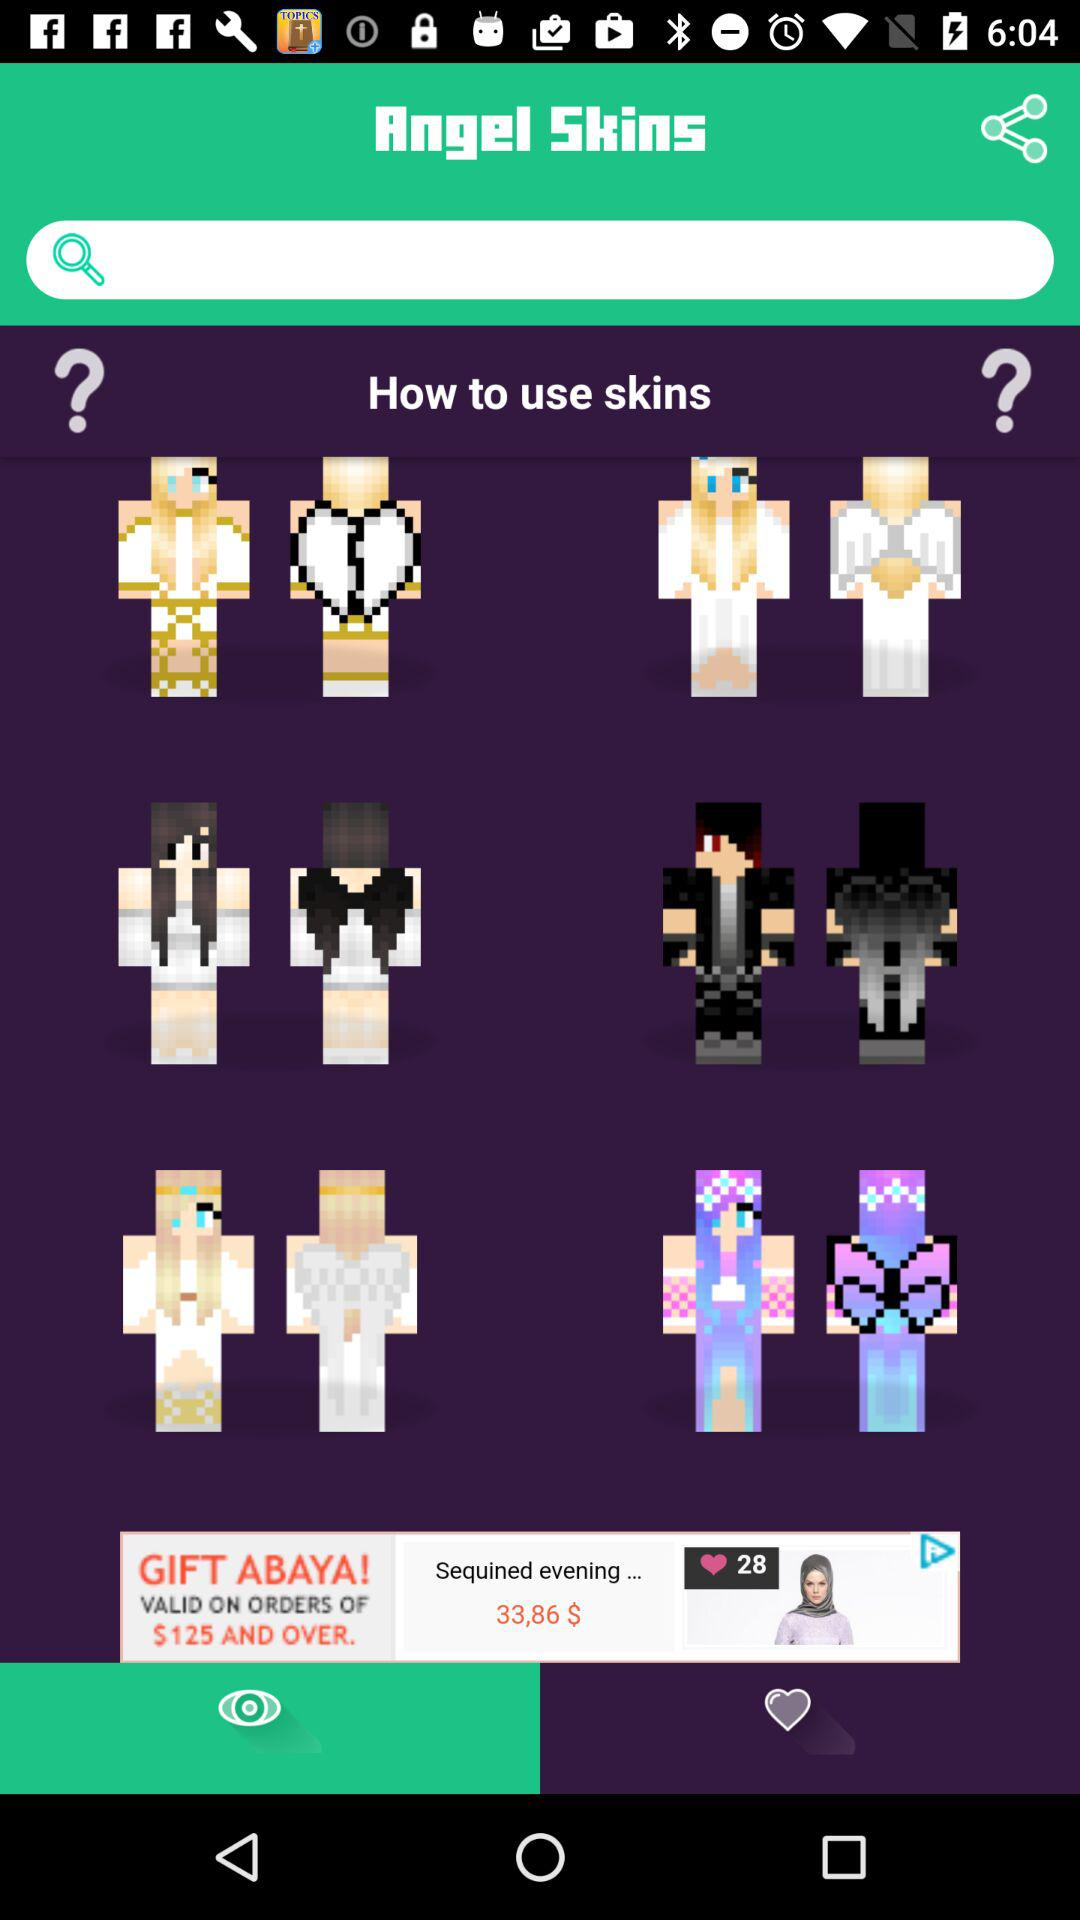What is the name of the application? The name of the application is "Angel Skins". 